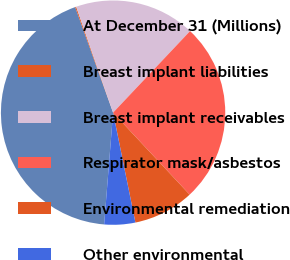Convert chart. <chart><loc_0><loc_0><loc_500><loc_500><pie_chart><fcel>At December 31 (Millions)<fcel>Breast implant liabilities<fcel>Breast implant receivables<fcel>Respirator mask/asbestos<fcel>Environmental remediation<fcel>Other environmental<nl><fcel>43.24%<fcel>0.15%<fcel>17.38%<fcel>26.0%<fcel>8.77%<fcel>4.46%<nl></chart> 